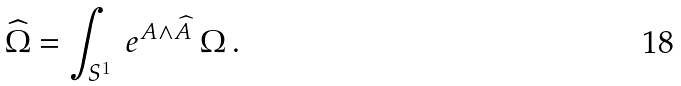Convert formula to latex. <formula><loc_0><loc_0><loc_500><loc_500>\widehat { \Omega } = \int _ { S ^ { 1 } } \ e ^ { A \wedge \widehat { A } } \ \Omega \, .</formula> 